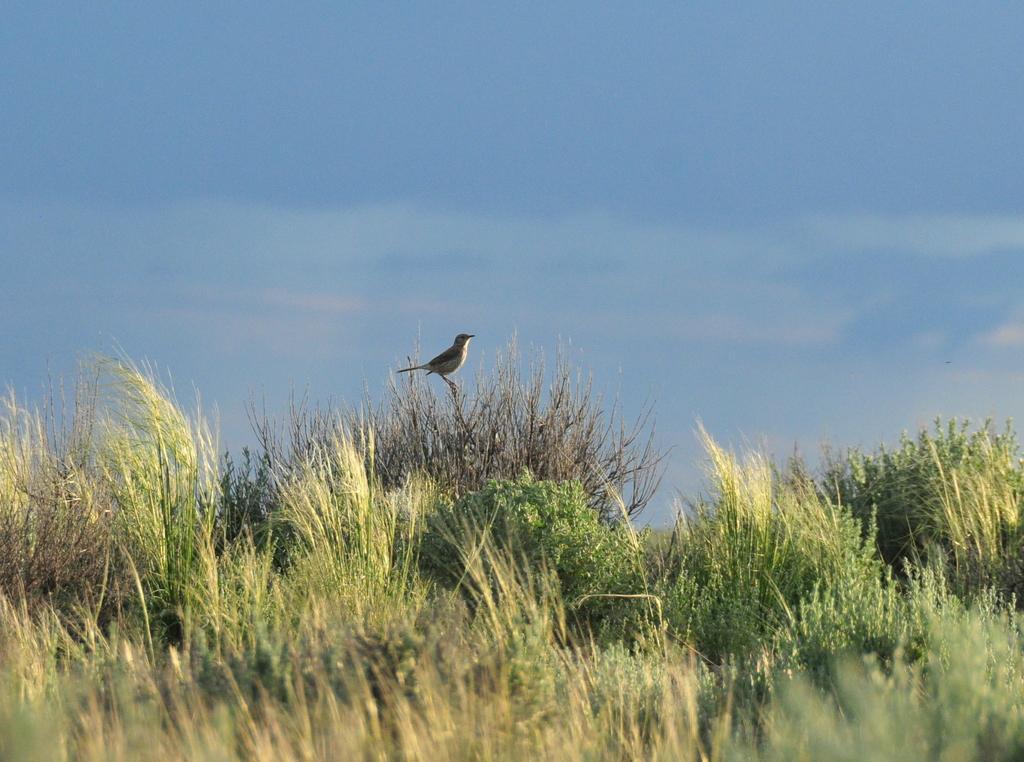Can you describe this image briefly? In this image we can see a bird on a plant. At the bottom of the image there is grass. In the background of the image there is sky. 